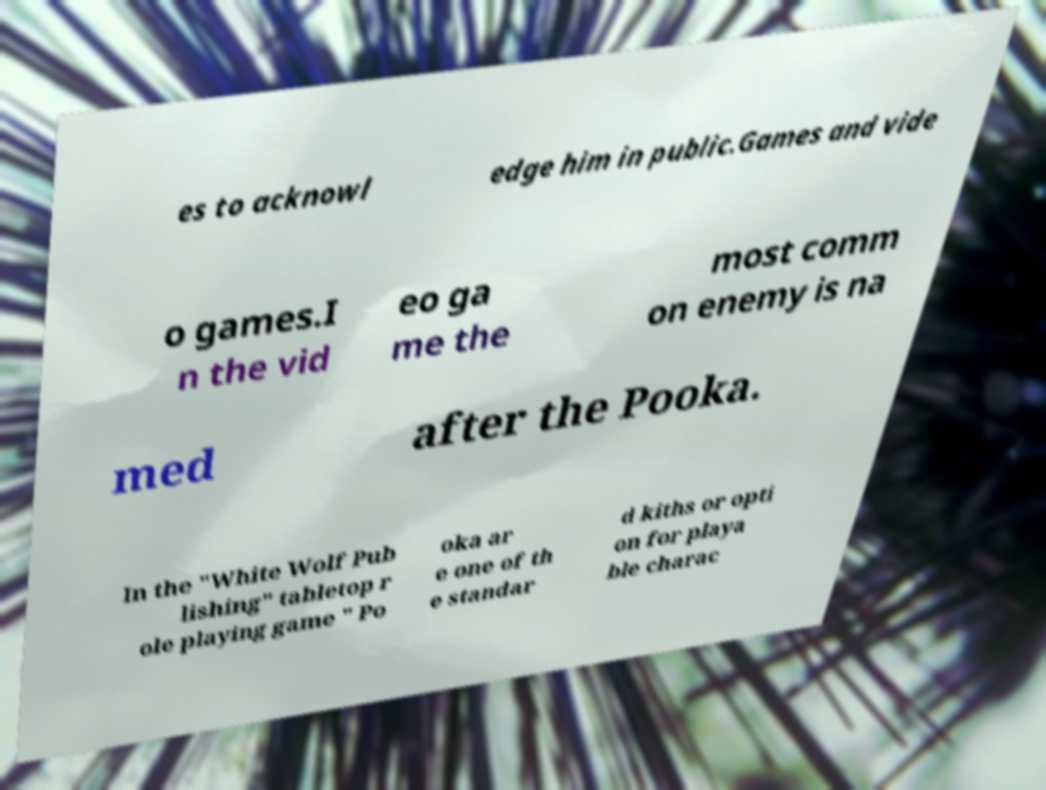Could you assist in decoding the text presented in this image and type it out clearly? es to acknowl edge him in public.Games and vide o games.I n the vid eo ga me the most comm on enemy is na med after the Pooka. In the "White Wolf Pub lishing" tabletop r ole playing game " Po oka ar e one of th e standar d kiths or opti on for playa ble charac 